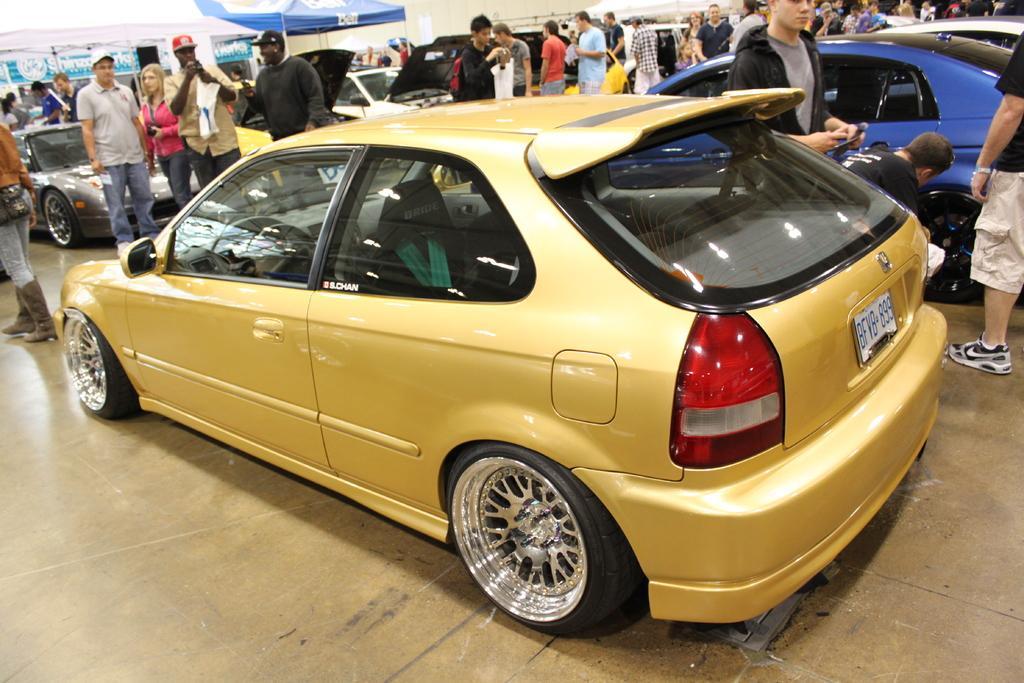Could you give a brief overview of what you see in this image? In this picture I can see vehicles, there are group of people standing, there are banners, there are gazebo tents. 